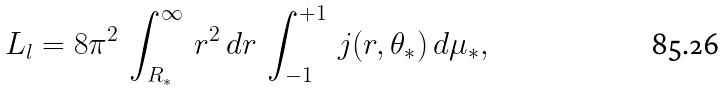<formula> <loc_0><loc_0><loc_500><loc_500>L _ { l } = 8 \pi ^ { 2 } \, \int _ { R _ { * } } ^ { \infty } \, r ^ { 2 } \, d r \, \int _ { - 1 } ^ { + 1 } \, j ( r , \theta _ { * } ) \, d \mu _ { * } ,</formula> 